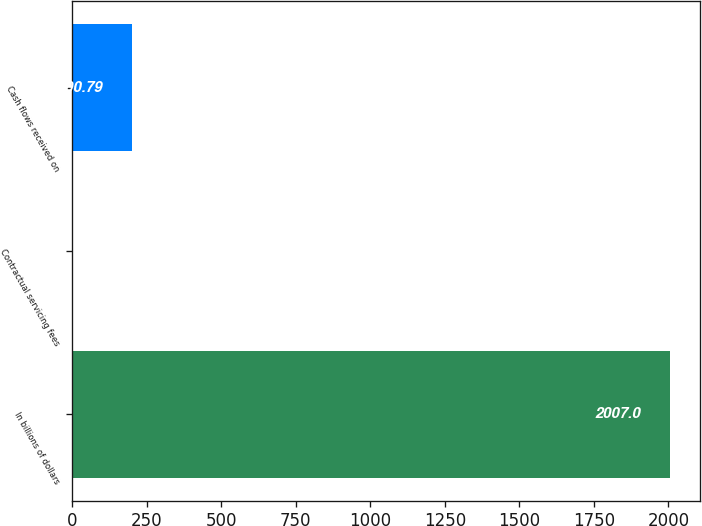<chart> <loc_0><loc_0><loc_500><loc_500><bar_chart><fcel>In billions of dollars<fcel>Contractual servicing fees<fcel>Cash flows received on<nl><fcel>2007<fcel>0.1<fcel>200.79<nl></chart> 